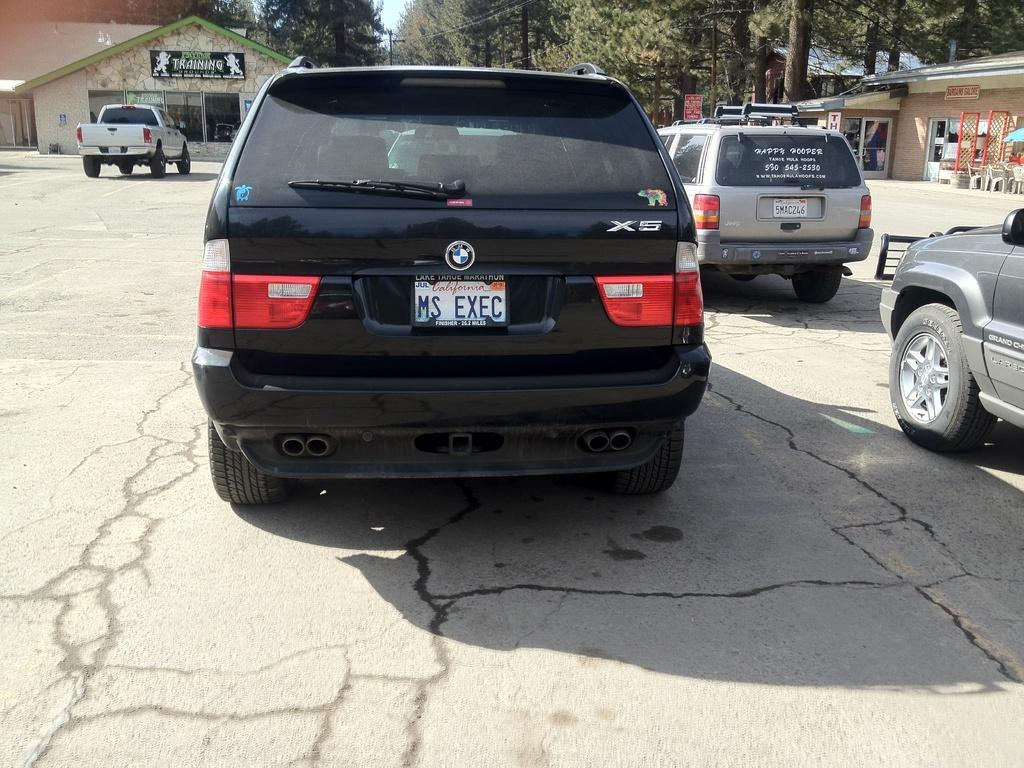<image>
Give a short and clear explanation of the subsequent image. the black BMW X5 is from California, USA 